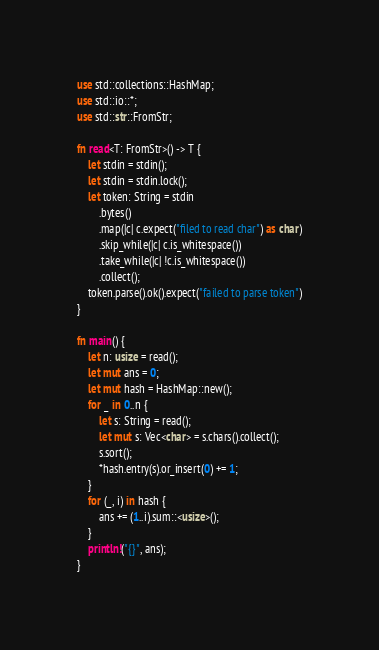Convert code to text. <code><loc_0><loc_0><loc_500><loc_500><_Rust_>use std::collections::HashMap;
use std::io::*;
use std::str::FromStr;

fn read<T: FromStr>() -> T {
    let stdin = stdin();
    let stdin = stdin.lock();
    let token: String = stdin
        .bytes()
        .map(|c| c.expect("filed to read char") as char)
        .skip_while(|c| c.is_whitespace())
        .take_while(|c| !c.is_whitespace())
        .collect();
    token.parse().ok().expect("failed to parse token")
}

fn main() {
    let n: usize = read();
    let mut ans = 0;
    let mut hash = HashMap::new();
    for _ in 0..n {
        let s: String = read();
        let mut s: Vec<char> = s.chars().collect();
        s.sort();
        *hash.entry(s).or_insert(0) += 1;
    }
    for (_, i) in hash {
        ans += (1..i).sum::<usize>();
    }
    println!("{}", ans);
}
</code> 